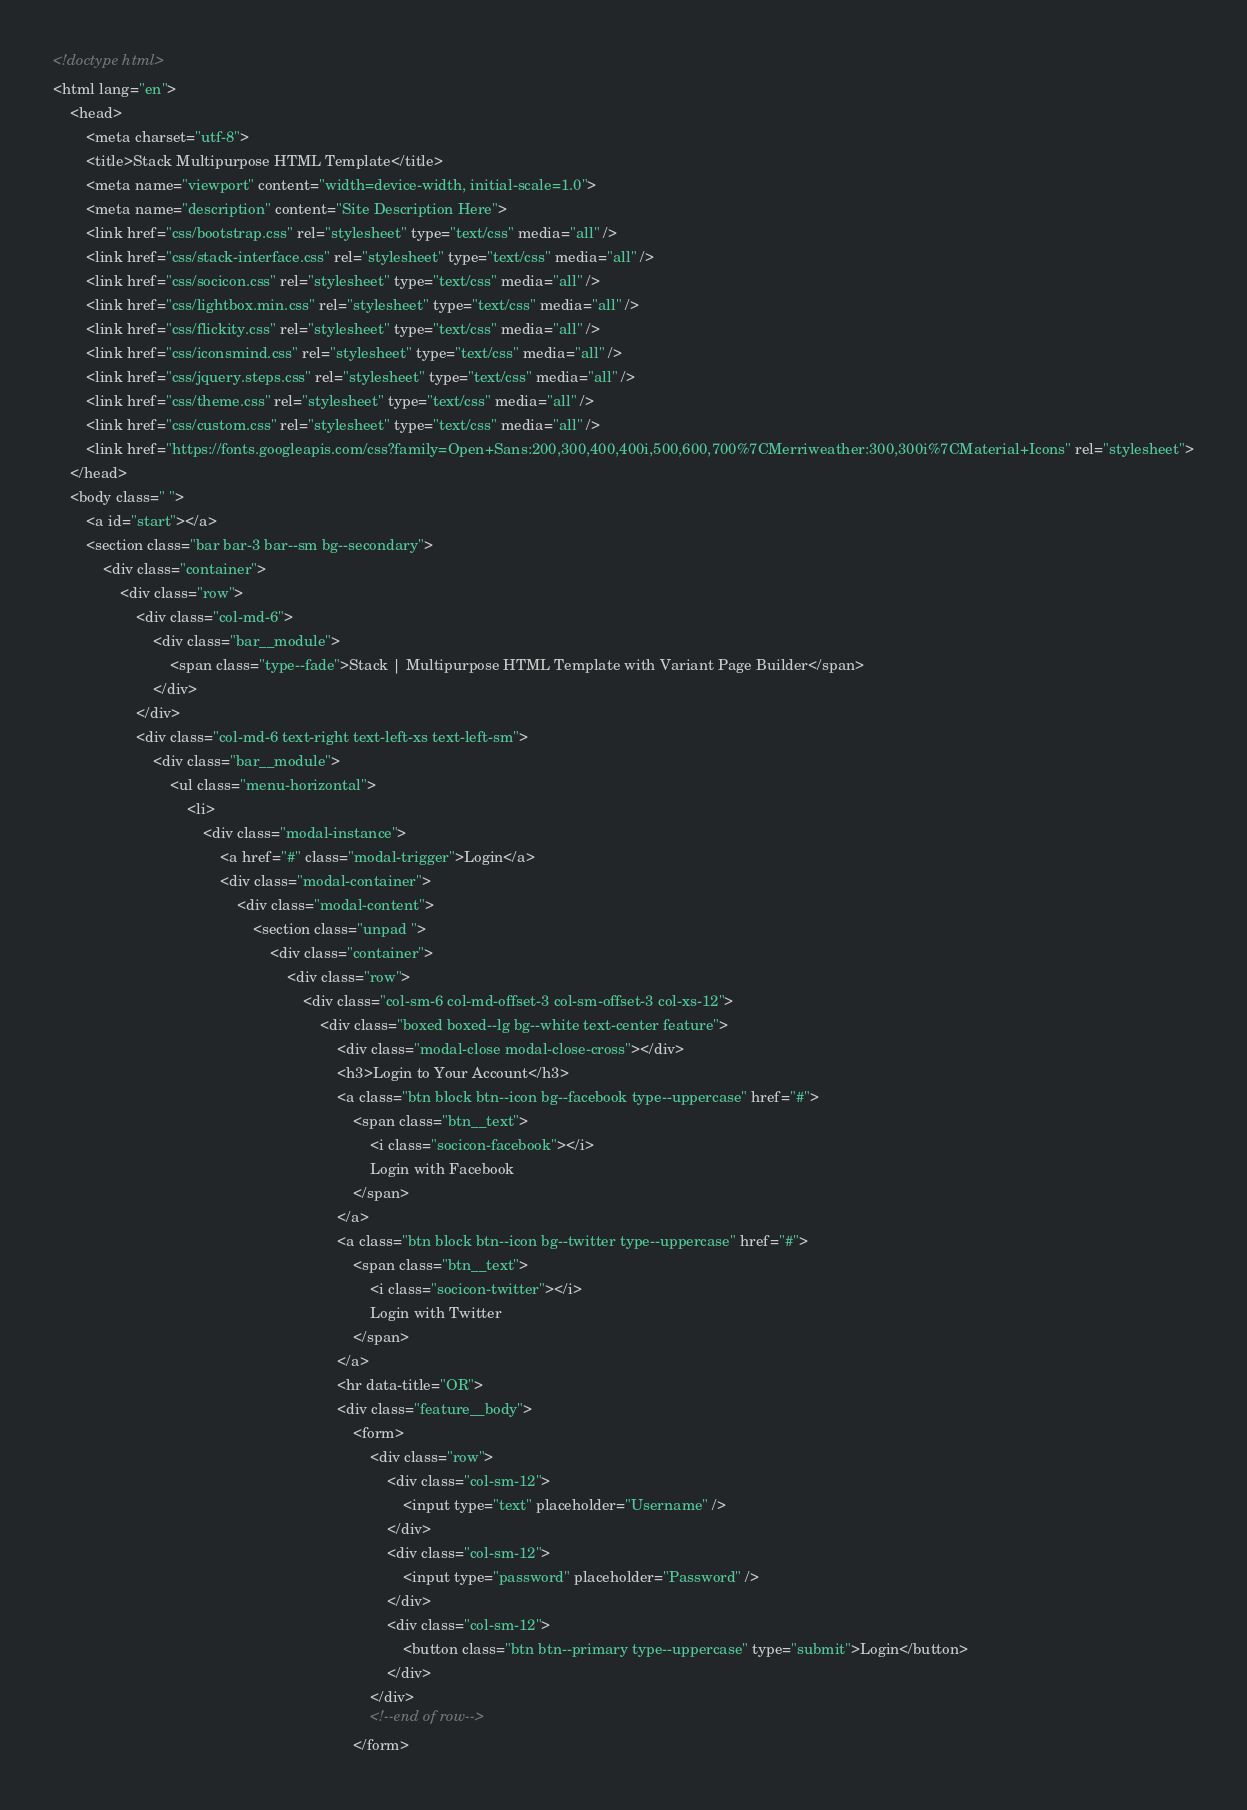Convert code to text. <code><loc_0><loc_0><loc_500><loc_500><_HTML_><!doctype html>
<html lang="en">
    <head>
        <meta charset="utf-8">
        <title>Stack Multipurpose HTML Template</title>
        <meta name="viewport" content="width=device-width, initial-scale=1.0">
        <meta name="description" content="Site Description Here">
        <link href="css/bootstrap.css" rel="stylesheet" type="text/css" media="all" />
        <link href="css/stack-interface.css" rel="stylesheet" type="text/css" media="all" />
        <link href="css/socicon.css" rel="stylesheet" type="text/css" media="all" />
        <link href="css/lightbox.min.css" rel="stylesheet" type="text/css" media="all" />
        <link href="css/flickity.css" rel="stylesheet" type="text/css" media="all" />
        <link href="css/iconsmind.css" rel="stylesheet" type="text/css" media="all" />
        <link href="css/jquery.steps.css" rel="stylesheet" type="text/css" media="all" />
        <link href="css/theme.css" rel="stylesheet" type="text/css" media="all" />
        <link href="css/custom.css" rel="stylesheet" type="text/css" media="all" />
        <link href="https://fonts.googleapis.com/css?family=Open+Sans:200,300,400,400i,500,600,700%7CMerriweather:300,300i%7CMaterial+Icons" rel="stylesheet">
    </head>
    <body class=" ">
        <a id="start"></a>
        <section class="bar bar-3 bar--sm bg--secondary">
            <div class="container">
                <div class="row">
                    <div class="col-md-6">
                        <div class="bar__module">
                            <span class="type--fade">Stack | Multipurpose HTML Template with Variant Page Builder</span>
                        </div>
                    </div>
                    <div class="col-md-6 text-right text-left-xs text-left-sm">
                        <div class="bar__module">
                            <ul class="menu-horizontal">
                                <li>
                                    <div class="modal-instance">
                                        <a href="#" class="modal-trigger">Login</a>
                                        <div class="modal-container">
                                            <div class="modal-content">
                                                <section class="unpad ">
                                                    <div class="container">
                                                        <div class="row">
                                                            <div class="col-sm-6 col-md-offset-3 col-sm-offset-3 col-xs-12">
                                                                <div class="boxed boxed--lg bg--white text-center feature">
                                                                    <div class="modal-close modal-close-cross"></div>
                                                                    <h3>Login to Your Account</h3>
                                                                    <a class="btn block btn--icon bg--facebook type--uppercase" href="#">
                                                                        <span class="btn__text">
                                                                            <i class="socicon-facebook"></i>
                                                                            Login with Facebook
                                                                        </span>
                                                                    </a>
                                                                    <a class="btn block btn--icon bg--twitter type--uppercase" href="#">
                                                                        <span class="btn__text">
                                                                            <i class="socicon-twitter"></i>
                                                                            Login with Twitter
                                                                        </span>
                                                                    </a>
                                                                    <hr data-title="OR">
                                                                    <div class="feature__body">
                                                                        <form>
                                                                            <div class="row">
                                                                                <div class="col-sm-12">
                                                                                    <input type="text" placeholder="Username" />
                                                                                </div>
                                                                                <div class="col-sm-12">
                                                                                    <input type="password" placeholder="Password" />
                                                                                </div>
                                                                                <div class="col-sm-12">
                                                                                    <button class="btn btn--primary type--uppercase" type="submit">Login</button>
                                                                                </div>
                                                                            </div>
                                                                            <!--end of row-->
                                                                        </form></code> 